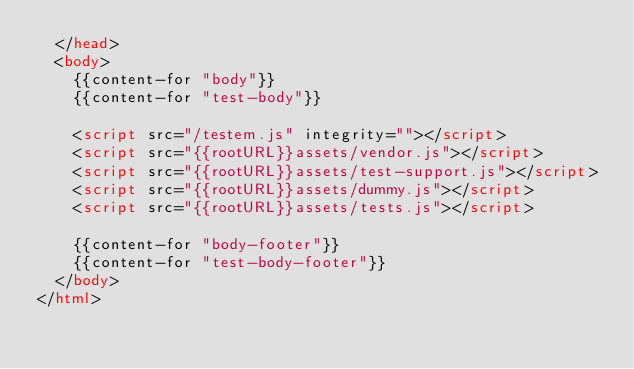Convert code to text. <code><loc_0><loc_0><loc_500><loc_500><_HTML_>  </head>
  <body>
    {{content-for "body"}}
    {{content-for "test-body"}}

    <script src="/testem.js" integrity=""></script>
    <script src="{{rootURL}}assets/vendor.js"></script>
    <script src="{{rootURL}}assets/test-support.js"></script>
    <script src="{{rootURL}}assets/dummy.js"></script>
    <script src="{{rootURL}}assets/tests.js"></script>

    {{content-for "body-footer"}}
    {{content-for "test-body-footer"}}
  </body>
</html>
</code> 